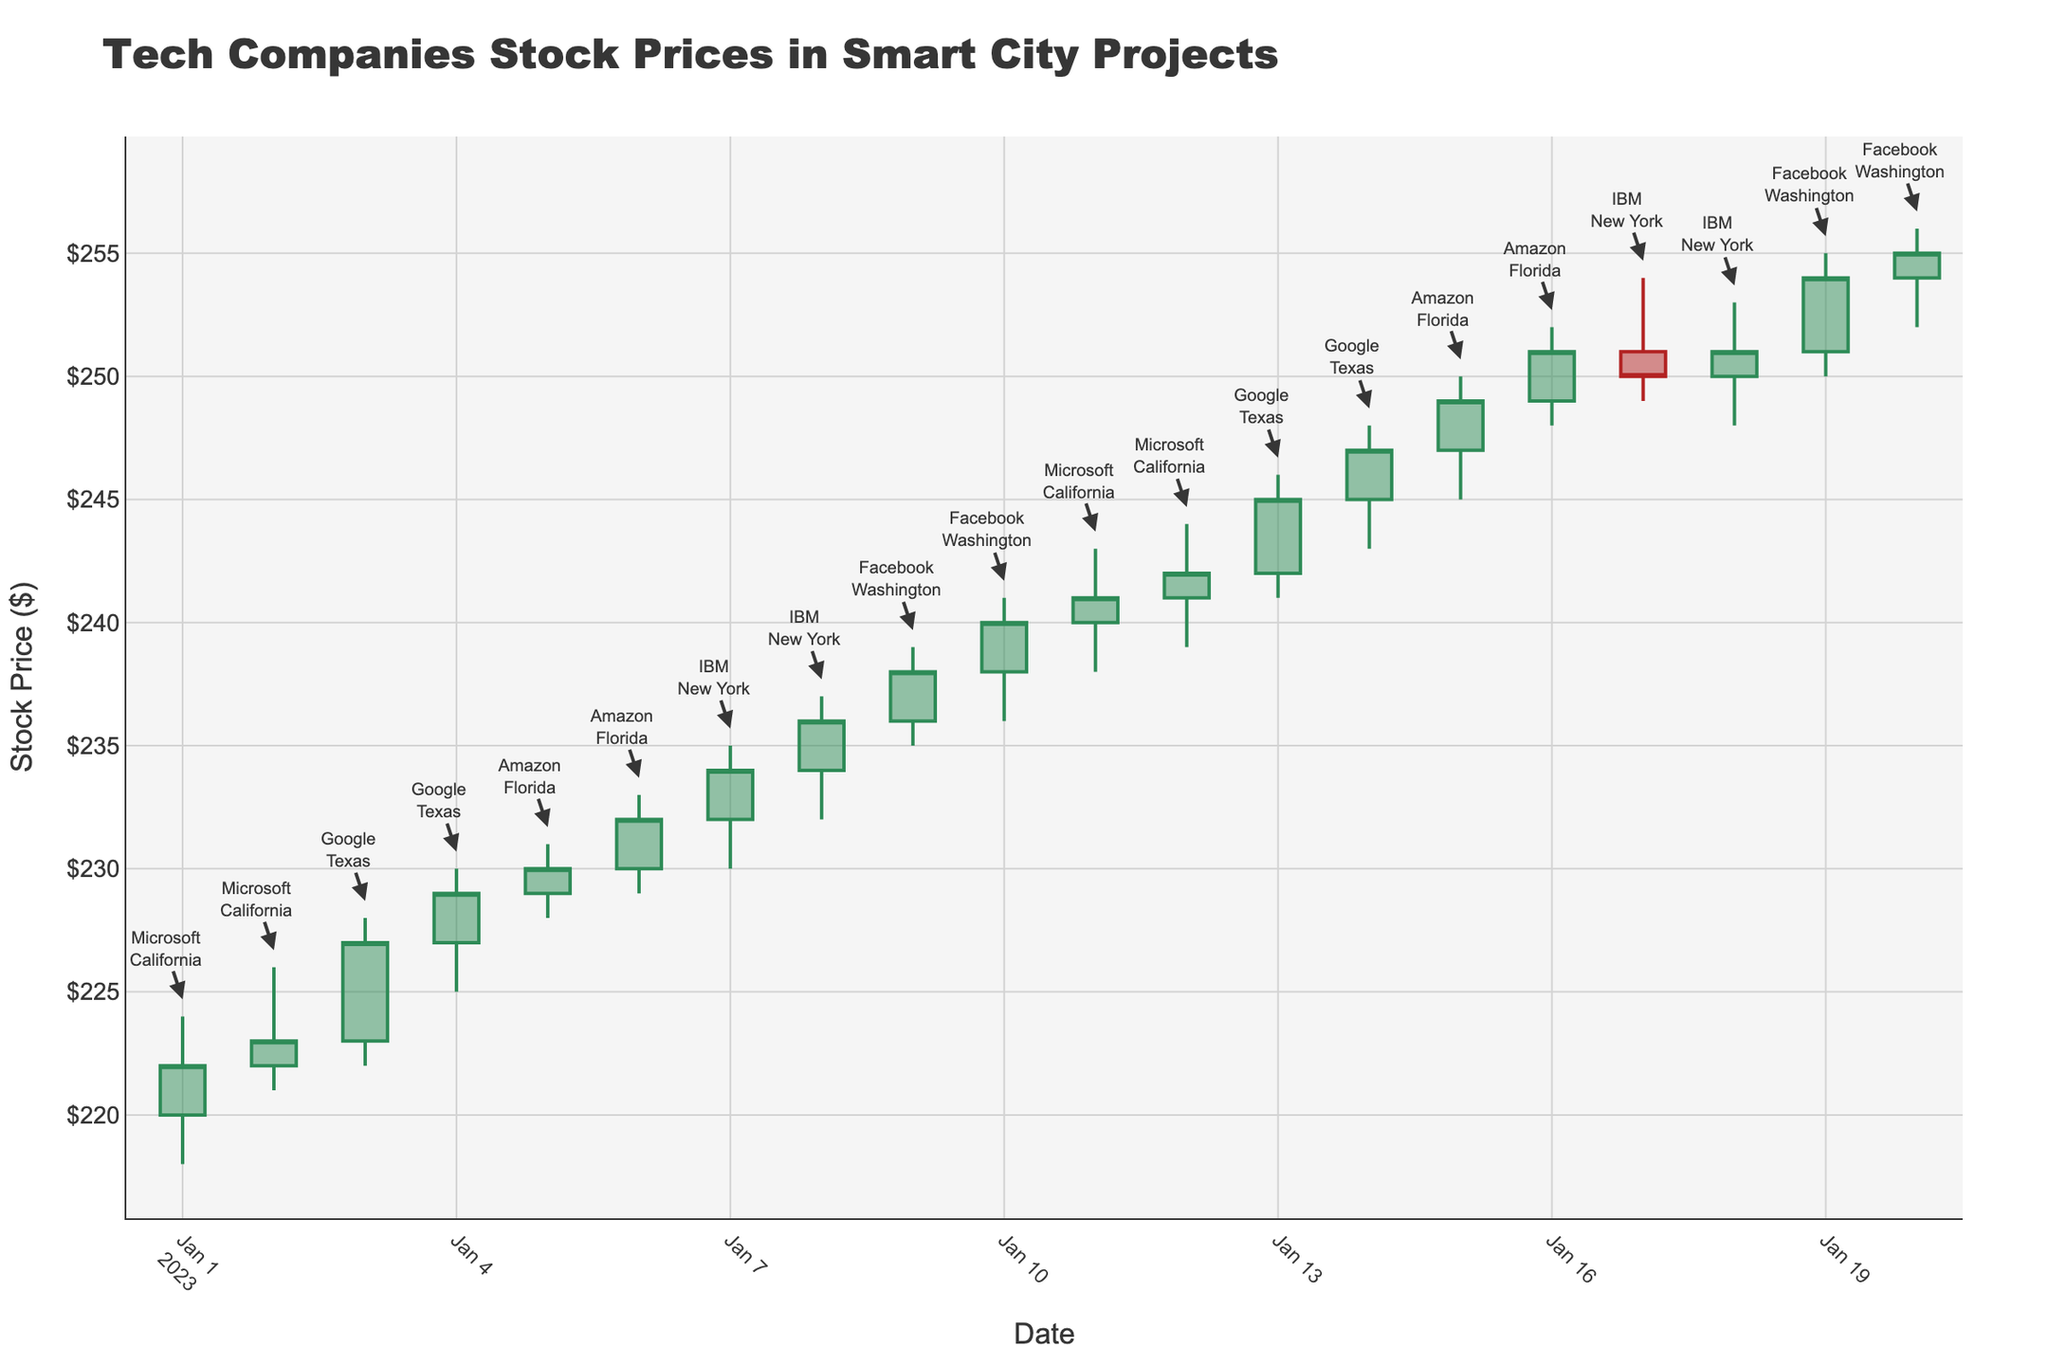What is the title of the plot? The title of the plot is displayed at the top and is usually in a larger and bolder font compared to other texts.
Answer: Tech Companies Stock Prices in Smart City Projects What are the date ranges in the x-axis? The x-axis shows the timeline over which the stock prices are plotted. By looking at the beginning and ending of the x-axis, we can determine the date range.
Answer: January 1, 2023 to January 20, 2023 Which company had the highest stock price during the observed period? Look for the tallest candle on the plot, which corresponds to the highest high value. The annotation near this candle provides the company name.
Answer: Facebook How many data points are there in total? Each candlestick represents one day of stock data. Count the number of candlesticks to find the total data points.
Answer: 20 Which company had stock prices shown on January 5th and January 6th? Locate the candlesticks corresponding to January 5th and January 6th, then read the annotation to identify the company.
Answer: Amazon What is the closing price of Amazon on January 6th? Find the candlestick for January 6th and look at the 'Close' part of the candlestick, noting the closing price.
Answer: $232 Which company has stock data visible in multiple states? Look for annotations that mention different states for the same company. Microsoft appears in California multiple times, and no other company spans different states in the given dataset.
Answer: Microsoft Compare the highest and lowest closing prices of Google's stock over the observed period. To find the highest and lowest closing prices, examine all the closing prices related to Google's stock. Identify the maximum and minimum values.
Answer: Highest: $249, Lowest: $227 Calculate the average volume for IBM's stock over the observed period. Sum the volumes for all days with IBM's stock data and divide by the number of such days.
Answer: (1550000 + 1350000 + 1120000 + 1340000) / 4 = 1340000 What state is associated with the first data point in the plot? Locate the first candlestick (January 1st) and check the annotation for the associated state.
Answer: California 